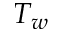Convert formula to latex. <formula><loc_0><loc_0><loc_500><loc_500>T _ { w }</formula> 